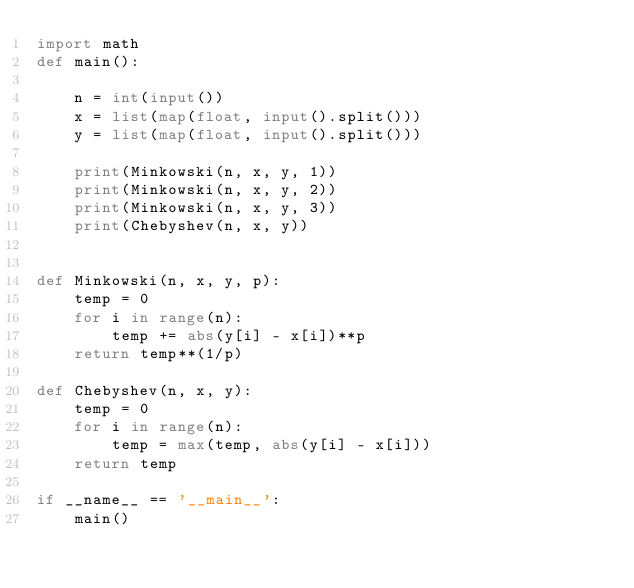<code> <loc_0><loc_0><loc_500><loc_500><_Python_>import math
def main():

    n = int(input())
    x = list(map(float, input().split()))
    y = list(map(float, input().split()))    

    print(Minkowski(n, x, y, 1))
    print(Minkowski(n, x, y, 2))
    print(Minkowski(n, x, y, 3))
    print(Chebyshev(n, x, y))


def Minkowski(n, x, y, p):
    temp = 0
    for i in range(n):
        temp += abs(y[i] - x[i])**p
    return temp**(1/p)

def Chebyshev(n, x, y):
    temp = 0
    for i in range(n):
        temp = max(temp, abs(y[i] - x[i]))
    return temp

if __name__ == '__main__':
    main()


</code> 